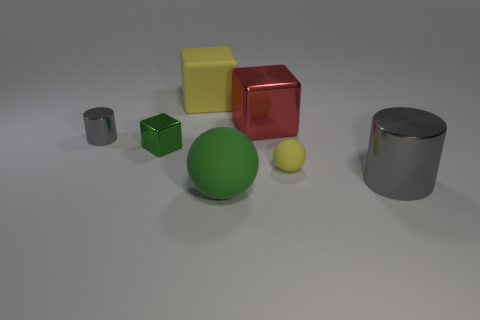Is there any other thing that has the same shape as the large yellow matte object?
Give a very brief answer. Yes. Is there a large shiny cylinder?
Provide a short and direct response. Yes. Do the small rubber thing and the green matte thing that is in front of the big yellow matte block have the same shape?
Give a very brief answer. Yes. There is a green thing in front of the object to the right of the small yellow ball; what is its material?
Provide a short and direct response. Rubber. The big rubber cube is what color?
Offer a very short reply. Yellow. There is a large block on the left side of the big green ball; does it have the same color as the thing in front of the big cylinder?
Make the answer very short. No. The other metal thing that is the same shape as the big gray metal object is what size?
Offer a very short reply. Small. Is there a small cube that has the same color as the large rubber ball?
Your answer should be very brief. Yes. There is a object that is the same color as the tiny metal block; what is its material?
Your response must be concise. Rubber. How many big blocks are the same color as the big matte ball?
Make the answer very short. 0. 